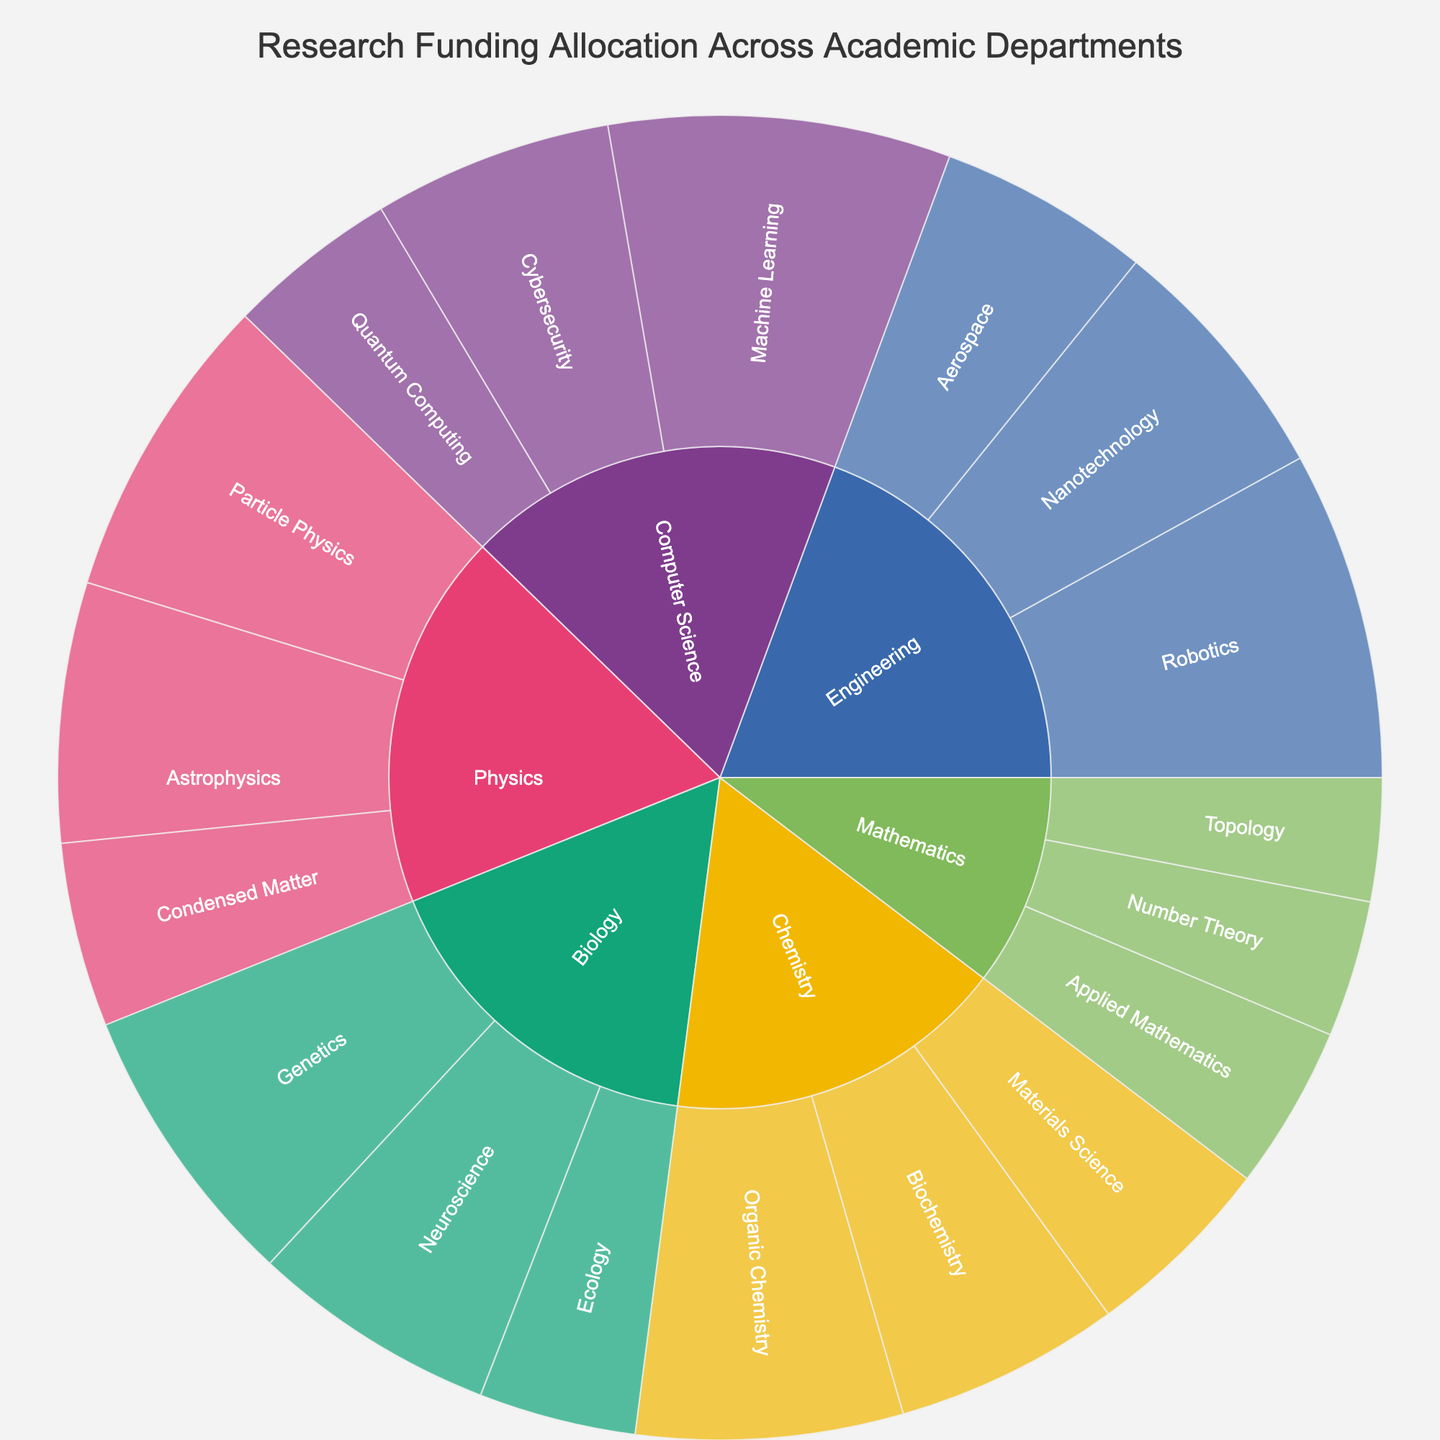What's the title of the plot? The title of the plot is located prominently at the top of the plot area, usually in a larger font size.
Answer: Research Funding Allocation Across Academic Departments Which department has the highest total funding allocation? To answer this, find the department section that takes up the largest space in the sunburst plot.
Answer: Computer Science How much funding is allocated to Quantum Computing? Locate the slice representing Quantum Computing under the Computer Science section by following the pathway and noting the funding information displayed.
Answer: $2,500,000 What is the total funding for Physics department? Sum the funding allocations for each research area within the Physics department: (Particle Physics: $4,500,000) + (Astrophysics: $3,800,000) + (Condensed Matter: $2,700,000).
Answer: $11,000,000 Compare the funding for Machine Learning and Robotics. Which has more? Locate the slices for Machine Learning and Robotics within their respective departments and compare the funding values observed in the hover data.
Answer: Machine Learning What percentage of the total funding is allocated to Neuroscience? Sum the total funding from all research areas ($60,280,000), then calculate the percentage for Neuroscience: ($3,600,000 / $60,280,000) * 100.
Answer: 5.97% Which research area in Chemistry has the lowest funding allocation? Identify the slices of each research area under Chemistry and find the one with the smallest funding value.
Answer: Materials Science What's the combined funding for Genetics and Ecology in the Biology department? Sum the funding allocations for Genetics ($4,200,000) and Ecology ($2,300,000) within the Biology section.
Answer: $6,500,000 Rank the departments by their total funding allocation from highest to lowest. Sum the funding allocations for each department: Computer Science ($11,000,000), Physics ($11,000,000), Biology ($10,100,000), Chemistry ($10,000,000), Engineering ($11,600,000), Mathematics ($6,200,000). Then, arrange them in descending order.
Answer: Engineering, Computer Science, Physics, Biology, Chemistry, Mathematics What is the funding difference between Number Theory and Applied Mathematics in the Mathematics department? Locate the slices for Number Theory and Applied Mathematics, and then subtract the funding allocation of Number Theory ($2,000,000) from Applied Mathematics ($2,400,000).
Answer: $400,000 